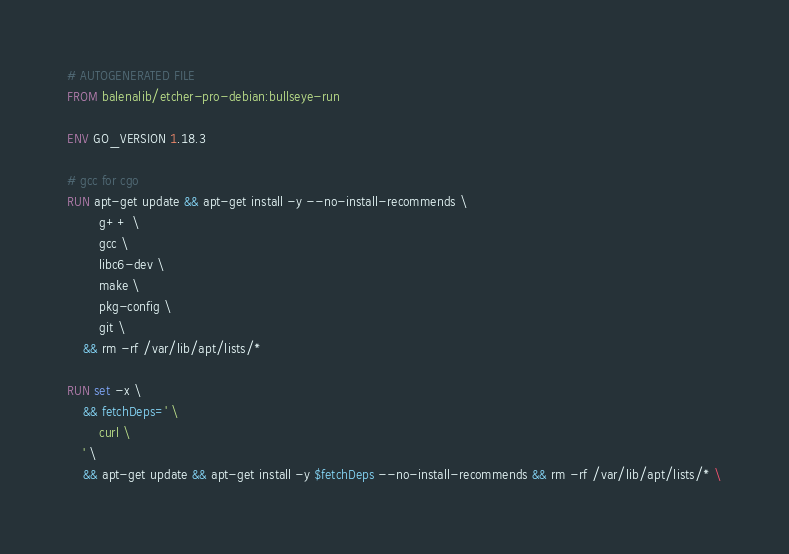<code> <loc_0><loc_0><loc_500><loc_500><_Dockerfile_># AUTOGENERATED FILE
FROM balenalib/etcher-pro-debian:bullseye-run

ENV GO_VERSION 1.18.3

# gcc for cgo
RUN apt-get update && apt-get install -y --no-install-recommends \
		g++ \
		gcc \
		libc6-dev \
		make \
		pkg-config \
		git \
	&& rm -rf /var/lib/apt/lists/*

RUN set -x \
	&& fetchDeps=' \
		curl \
	' \
	&& apt-get update && apt-get install -y $fetchDeps --no-install-recommends && rm -rf /var/lib/apt/lists/* \</code> 